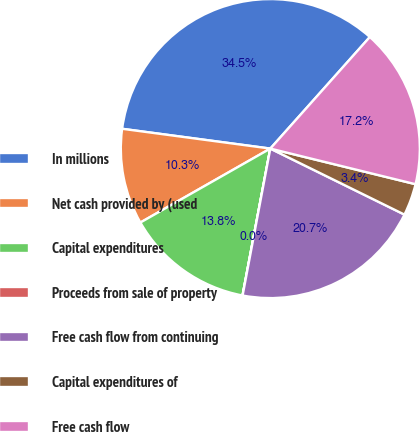<chart> <loc_0><loc_0><loc_500><loc_500><pie_chart><fcel>In millions<fcel>Net cash provided by (used<fcel>Capital expenditures<fcel>Proceeds from sale of property<fcel>Free cash flow from continuing<fcel>Capital expenditures of<fcel>Free cash flow<nl><fcel>34.48%<fcel>10.35%<fcel>13.79%<fcel>0.01%<fcel>20.69%<fcel>3.45%<fcel>17.24%<nl></chart> 